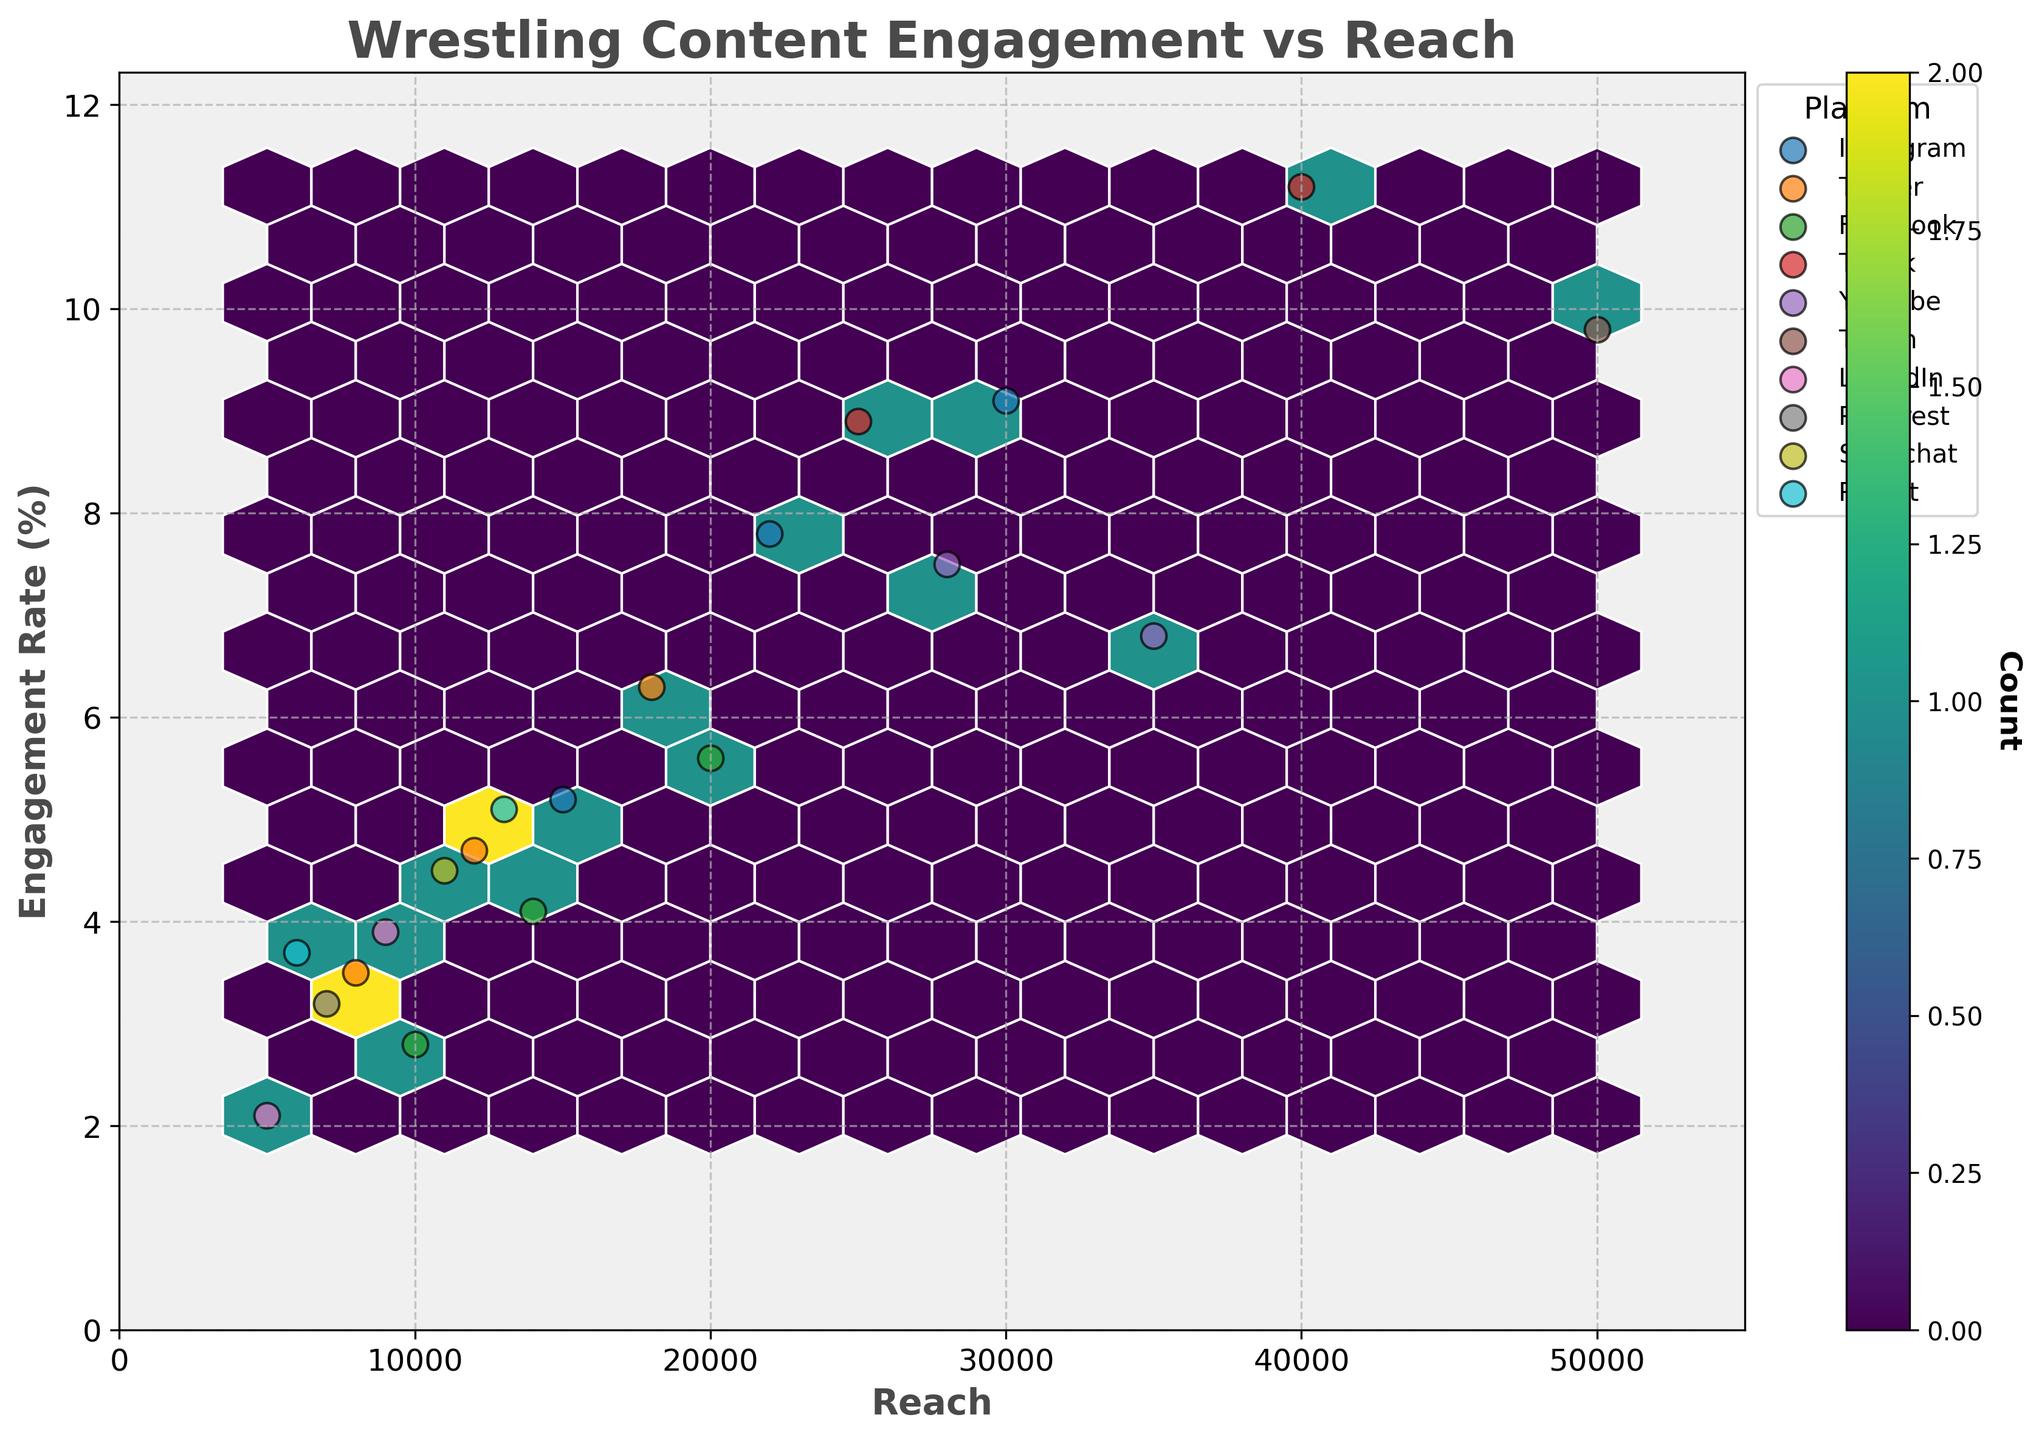What is the title of the plot? The title is prominently displayed at the top of the plot.
Answer: Wrestling Content Engagement vs Reach Which platform has the highest engagement rate? Identify the highest y-value (engagement rate) and check the corresponding platform label near the data point.
Answer: TikTok How many unique platforms are represented in the plot? By examining the legend, we can count the distinct platforms listed.
Answer: 10 In which reach range do we see the highest density of engagement rates? The plot uses color density to represent the number of data points in hexagonal bins. The region with the darkest color has the highest density.
Answer: 15,000-30,000 What is the engagement rate for Instagram Video posts? Look for the "Instagram" platform and match it with post types labeled "Video." Then, identify the associated y-value.
Answer: 7.8% Which platform has the widest range of reach values? Compare the reach values (x-axis) for each platform by looking at the scattered points and observing the spread.
Answer: Twitch How does the engagement rate for Facebook Photo posts compare to Snapchat Story posts? Find the points corresponding to Facebook Photo and Snapchat Story. Compare their y-values (engagement rates).
Answer: Facebook Photo (4.1%) is lower than Snapchat Story (4.5%) What's the average engagement rate across all platforms? Sum all engagement rates and divide by the number of data points to find the average.
Answer: (5.2 + 7.8 + 9.1 + 3.5 + 4.7 + 6.3 + 2.8 + 4.1 + 5.6 + 11.2 + 8.9 + 7.5 + 6.8 + 9.8 + 2.1 + 3.9 + 3.2 + 4.5 + 3.7 + 5.1) / 20 = 6.01% What platform shows an engagement rate exceeding 10%? Identify and verify the y-values above 10%. Examine which platform the points belong to.
Answer: TikTok Does Instagram have a broader distribution in reach compared to LinkedIn? Compare the x-axis spread (reach) of points for Instagram and LinkedIn. Examine their respective ranges.
Answer: Yes 